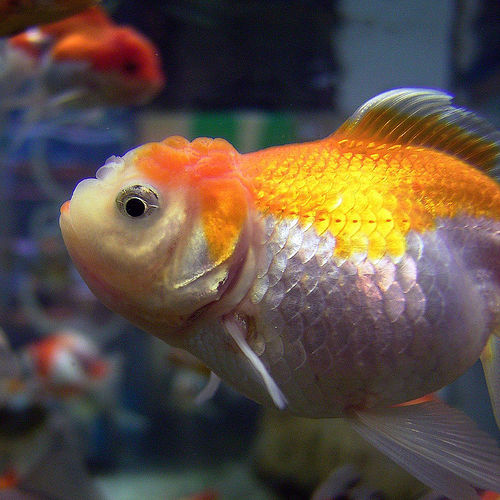<image>
Is there a fish on the water? No. The fish is not positioned on the water. They may be near each other, but the fish is not supported by or resting on top of the water. Where is the fish in relation to the other fish? Is it in front of the other fish? Yes. The fish is positioned in front of the other fish, appearing closer to the camera viewpoint. 